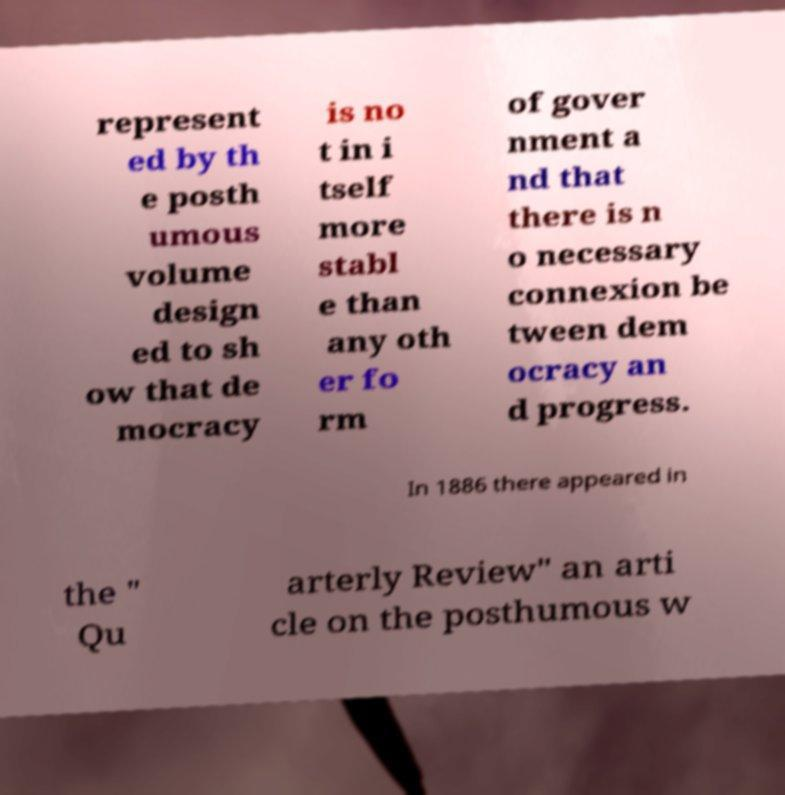Can you read and provide the text displayed in the image?This photo seems to have some interesting text. Can you extract and type it out for me? represent ed by th e posth umous volume design ed to sh ow that de mocracy is no t in i tself more stabl e than any oth er fo rm of gover nment a nd that there is n o necessary connexion be tween dem ocracy an d progress. In 1886 there appeared in the " Qu arterly Review" an arti cle on the posthumous w 